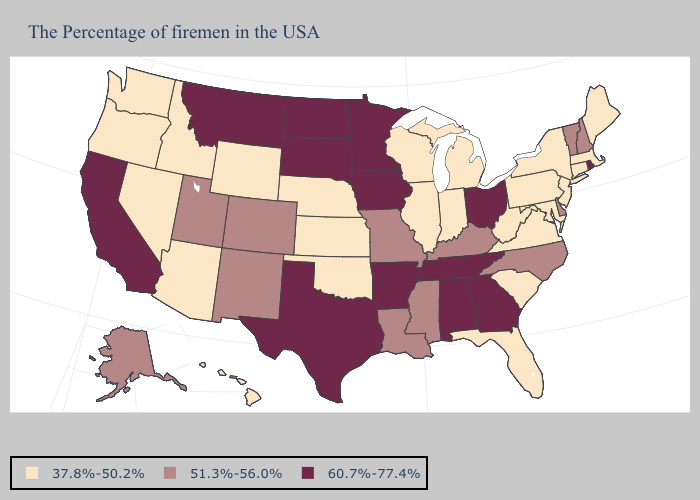Does the first symbol in the legend represent the smallest category?
Keep it brief. Yes. Name the states that have a value in the range 60.7%-77.4%?
Be succinct. Rhode Island, Ohio, Georgia, Alabama, Tennessee, Arkansas, Minnesota, Iowa, Texas, South Dakota, North Dakota, Montana, California. Among the states that border Mississippi , which have the lowest value?
Answer briefly. Louisiana. What is the value of Utah?
Short answer required. 51.3%-56.0%. Name the states that have a value in the range 60.7%-77.4%?
Write a very short answer. Rhode Island, Ohio, Georgia, Alabama, Tennessee, Arkansas, Minnesota, Iowa, Texas, South Dakota, North Dakota, Montana, California. Name the states that have a value in the range 51.3%-56.0%?
Be succinct. New Hampshire, Vermont, Delaware, North Carolina, Kentucky, Mississippi, Louisiana, Missouri, Colorado, New Mexico, Utah, Alaska. What is the value of Indiana?
Write a very short answer. 37.8%-50.2%. What is the highest value in the South ?
Give a very brief answer. 60.7%-77.4%. Name the states that have a value in the range 37.8%-50.2%?
Short answer required. Maine, Massachusetts, Connecticut, New York, New Jersey, Maryland, Pennsylvania, Virginia, South Carolina, West Virginia, Florida, Michigan, Indiana, Wisconsin, Illinois, Kansas, Nebraska, Oklahoma, Wyoming, Arizona, Idaho, Nevada, Washington, Oregon, Hawaii. Which states have the highest value in the USA?
Write a very short answer. Rhode Island, Ohio, Georgia, Alabama, Tennessee, Arkansas, Minnesota, Iowa, Texas, South Dakota, North Dakota, Montana, California. Name the states that have a value in the range 37.8%-50.2%?
Concise answer only. Maine, Massachusetts, Connecticut, New York, New Jersey, Maryland, Pennsylvania, Virginia, South Carolina, West Virginia, Florida, Michigan, Indiana, Wisconsin, Illinois, Kansas, Nebraska, Oklahoma, Wyoming, Arizona, Idaho, Nevada, Washington, Oregon, Hawaii. What is the value of Massachusetts?
Be succinct. 37.8%-50.2%. Does Rhode Island have the highest value in the USA?
Give a very brief answer. Yes. Does Missouri have a lower value than Ohio?
Concise answer only. Yes. 